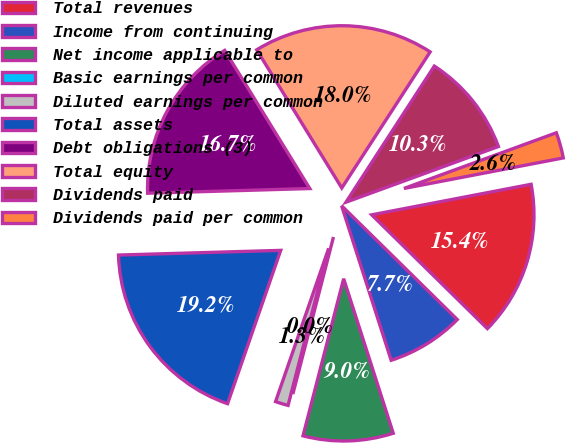Convert chart to OTSL. <chart><loc_0><loc_0><loc_500><loc_500><pie_chart><fcel>Total revenues<fcel>Income from continuing<fcel>Net income applicable to<fcel>Basic earnings per common<fcel>Diluted earnings per common<fcel>Total assets<fcel>Debt obligations (3)<fcel>Total equity<fcel>Dividends paid<fcel>Dividends paid per common<nl><fcel>15.38%<fcel>7.69%<fcel>8.97%<fcel>0.0%<fcel>1.28%<fcel>19.23%<fcel>16.67%<fcel>17.95%<fcel>10.26%<fcel>2.56%<nl></chart> 